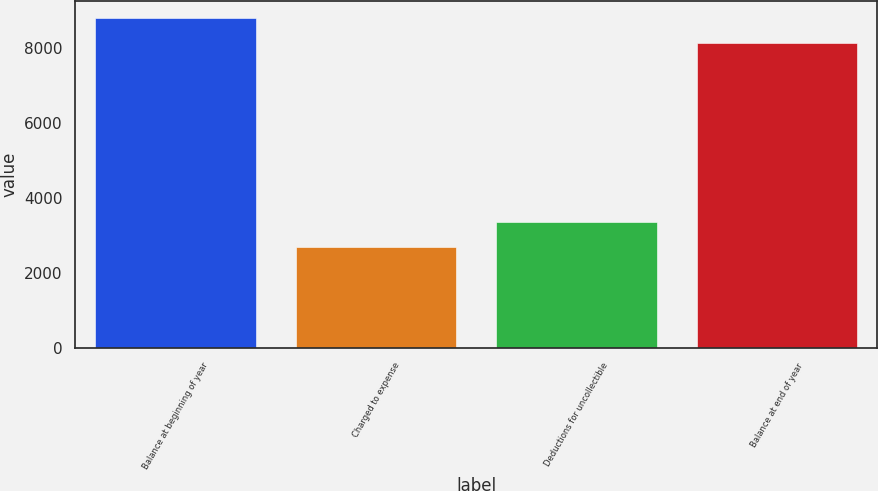Convert chart to OTSL. <chart><loc_0><loc_0><loc_500><loc_500><bar_chart><fcel>Balance at beginning of year<fcel>Charged to expense<fcel>Deductions for uncollectible<fcel>Balance at end of year<nl><fcel>8802<fcel>2690<fcel>3373<fcel>8119<nl></chart> 